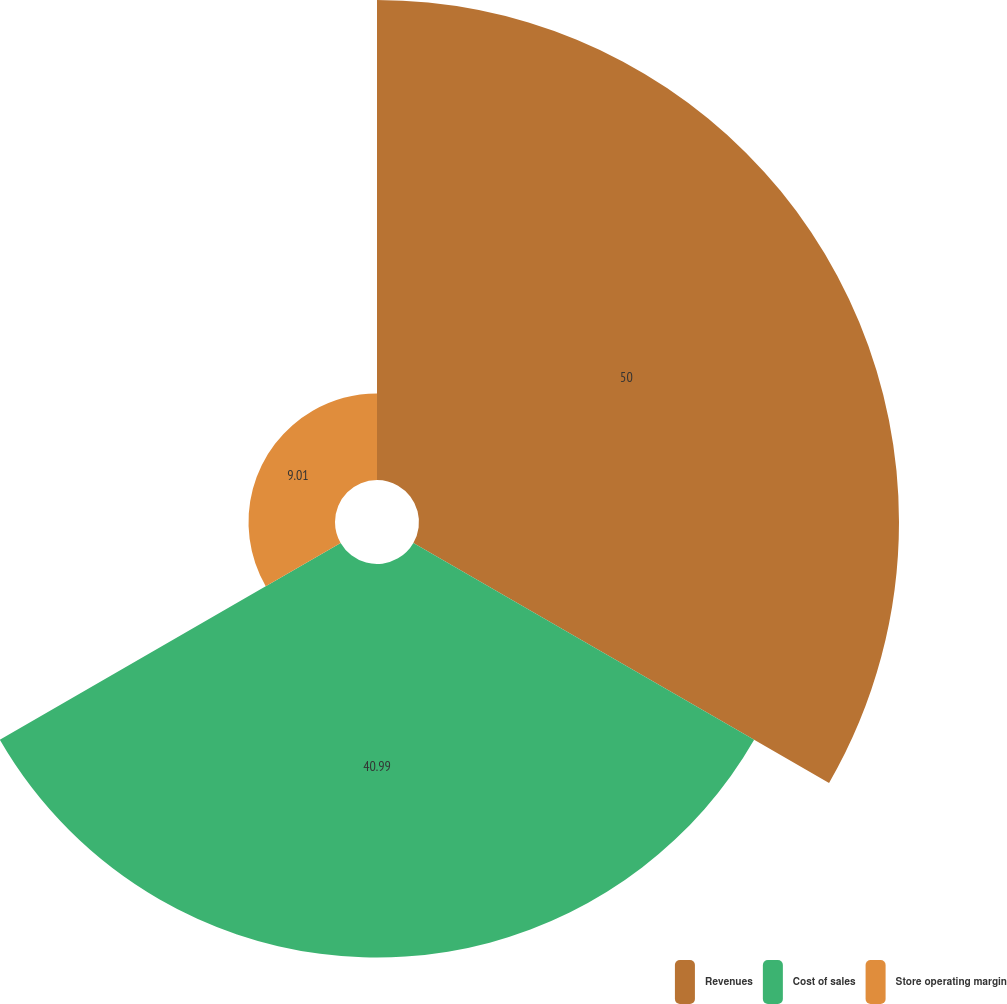Convert chart. <chart><loc_0><loc_0><loc_500><loc_500><pie_chart><fcel>Revenues<fcel>Cost of sales<fcel>Store operating margin<nl><fcel>50.0%<fcel>40.99%<fcel>9.01%<nl></chart> 